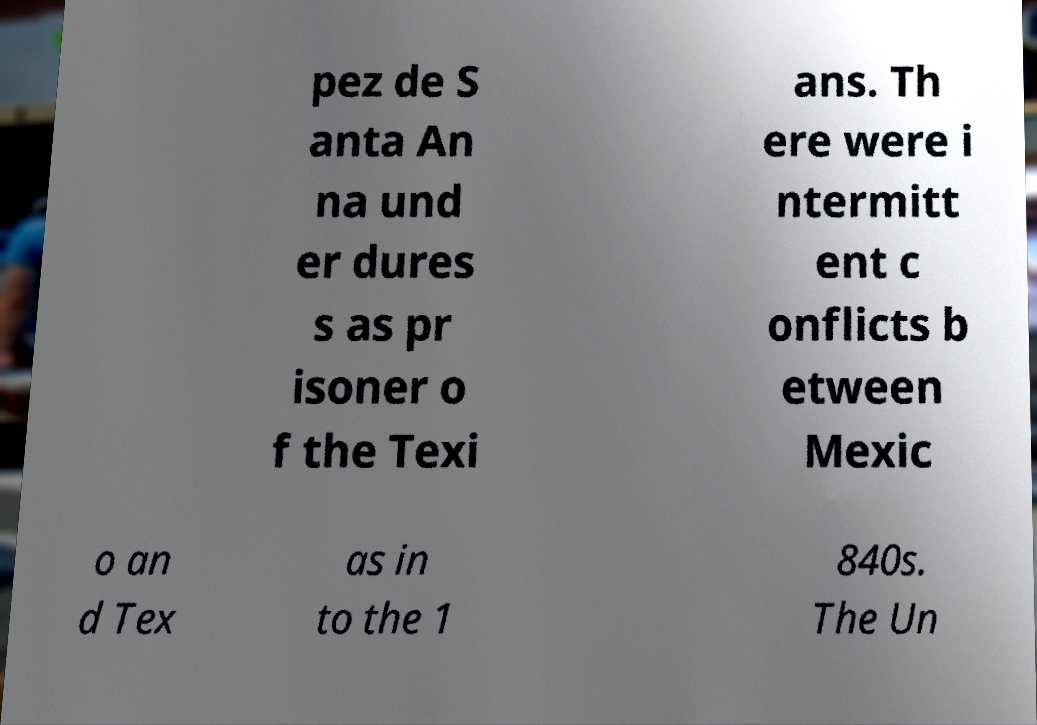Could you extract and type out the text from this image? pez de S anta An na und er dures s as pr isoner o f the Texi ans. Th ere were i ntermitt ent c onflicts b etween Mexic o an d Tex as in to the 1 840s. The Un 